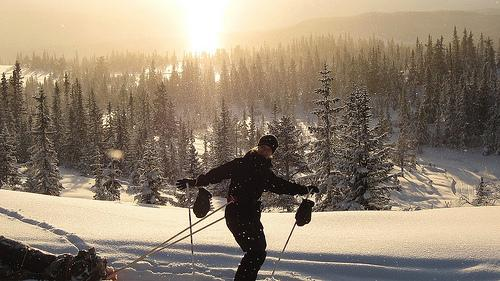Explain the appearance of the snow in the image. The snow is white and perfectly smooth, covering the ground, trees, and mountain. What color are the trees in the snowy image? The trees are green but partially covered by the white snow. What are the clothing items worn by the person in the image? The person is wearing a black jacket, black gloves, and black pants. What is the primary setting and background of the image? A snow-covered mountain with a clear sky, trees, and an abundance of snow. Count the number of trees mentioned in the image and provide a brief description of their appearance. There are numerous trees, all covered by snow to varying degrees. Mention three different objects being held by the person in the image. The person is holding ski poles. List three different appearances of sunlight in the image. Sun in the sky, sunlight casting shadows, and sun shining over the mountains. Describe the weather conditions in the image. The sky is clear with the sun shining, casting shadows on the snow-covered ground. Identify the main activity taking place in the image involving a person. A person skiing, holding ski poles, and wearing skiing gear on a snow-covered mountain. 